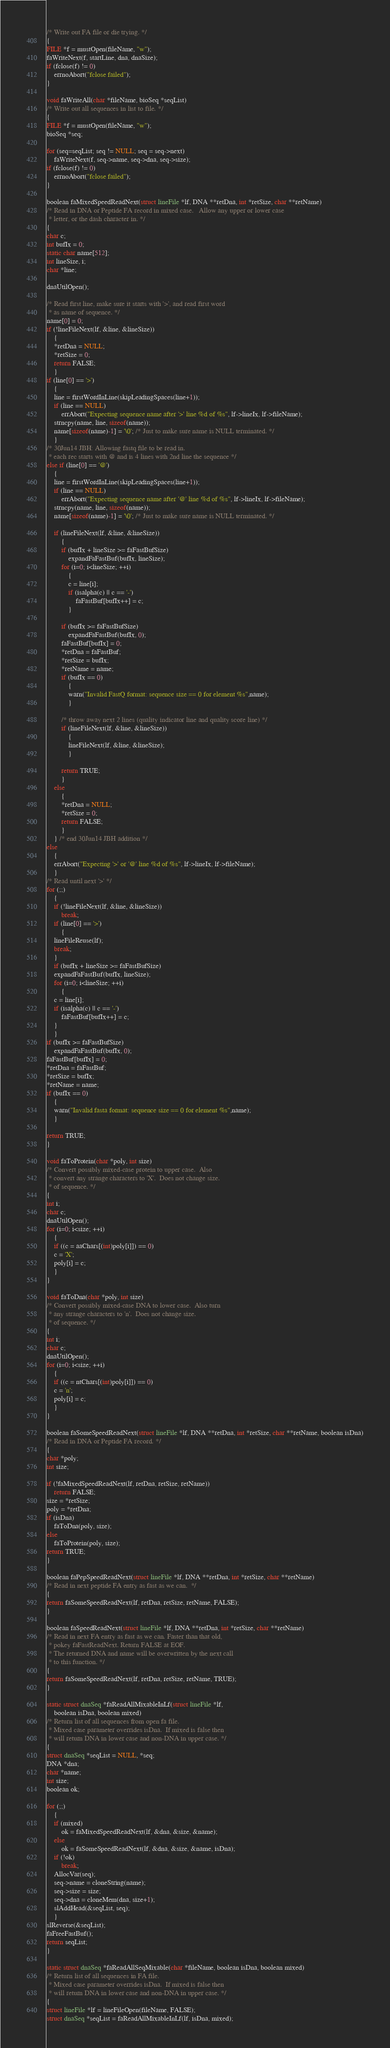<code> <loc_0><loc_0><loc_500><loc_500><_C_>/* Write out FA file or die trying. */
{
FILE *f = mustOpen(fileName, "w");
faWriteNext(f, startLine, dna, dnaSize);
if (fclose(f) != 0)
    errnoAbort("fclose failed");
}

void faWriteAll(char *fileName, bioSeq *seqList)
/* Write out all sequences in list to file. */
{
FILE *f = mustOpen(fileName, "w");
bioSeq *seq;

for (seq=seqList; seq != NULL; seq = seq->next)
    faWriteNext(f, seq->name, seq->dna, seq->size);
if (fclose(f) != 0)
    errnoAbort("fclose failed");
}

boolean faMixedSpeedReadNext(struct lineFile *lf, DNA **retDna, int *retSize, char **retName)
/* Read in DNA or Peptide FA record in mixed case.   Allow any upper or lower case
 * letter, or the dash character in. */
{
char c;
int bufIx = 0;
static char name[512];
int lineSize, i;
char *line;

dnaUtilOpen();

/* Read first line, make sure it starts with '>', and read first word
 * as name of sequence. */
name[0] = 0;
if (!lineFileNext(lf, &line, &lineSize))
    {
    *retDna = NULL;
    *retSize = 0;
    return FALSE;
    }
if (line[0] == '>')
    {
    line = firstWordInLine(skipLeadingSpaces(line+1));
    if (line == NULL)
        errAbort("Expecting sequence name after '>' line %d of %s", lf->lineIx, lf->fileName);
    strncpy(name, line, sizeof(name));
    name[sizeof(name)-1] = '\0'; /* Just to make sure name is NULL terminated. */
    }
/* 30Jun14 JBH: Allowing fastq file to be read in.
 * each rec starts with @ and is 4 lines with 2nd line the sequence */
else if (line[0] == '@')
	{
    line = firstWordInLine(skipLeadingSpaces(line+1));
    if (line == NULL)
        errAbort("Expecting sequence name after '@' line %d of %s", lf->lineIx, lf->fileName);
    strncpy(name, line, sizeof(name));
    name[sizeof(name)-1] = '\0'; /* Just to make sure name is NULL terminated. */

    if (lineFileNext(lf, &line, &lineSize))
		{
		if (bufIx + lineSize >= faFastBufSize)
			expandFaFastBuf(bufIx, lineSize);
		for (i=0; i<lineSize; ++i)
			{
			c = line[i];
			if (isalpha(c) || c == '-')
				faFastBuf[bufIx++] = c;
			}

		if (bufIx >= faFastBufSize)
			expandFaFastBuf(bufIx, 0);
		faFastBuf[bufIx] = 0;
		*retDna = faFastBuf;
		*retSize = bufIx;
		*retName = name;
		if (bufIx == 0)
			{
			warn("Invalid FastQ format: sequence size == 0 for element %s",name);
			}
			
		/* throw away next 2 lines (quality indicator line and quality score line) */
		if (lineFileNext(lf, &line, &lineSize))
			{
		    lineFileNext(lf, &line, &lineSize);
			}
			
		return TRUE;
		}
	else
		{
		*retDna = NULL;
		*retSize = 0;
		return FALSE;
		}
	} /* end 30Jun14 JBH addition */
else
    {
    errAbort("Expecting '>' or '@' line %d of %s", lf->lineIx, lf->fileName);
    }
/* Read until next '>' */
for (;;)
    {
    if (!lineFileNext(lf, &line, &lineSize))
        break;
    if (line[0] == '>')
        {
	lineFileReuse(lf);
	break;
	}
    if (bufIx + lineSize >= faFastBufSize)
	expandFaFastBuf(bufIx, lineSize);
    for (i=0; i<lineSize; ++i)
        {
	c = line[i];
	if (isalpha(c) || c == '-')
	    faFastBuf[bufIx++] = c;
	}
    }
if (bufIx >= faFastBufSize)
    expandFaFastBuf(bufIx, 0);
faFastBuf[bufIx] = 0;
*retDna = faFastBuf;
*retSize = bufIx;
*retName = name;
if (bufIx == 0)
    {
    warn("Invalid fasta format: sequence size == 0 for element %s",name);
    }

return TRUE;
}

void faToProtein(char *poly, int size)
/* Convert possibly mixed-case protein to upper case.  Also
 * convert any strange characters to 'X'.  Does not change size.
 * of sequence. */
{
int i;
char c;
dnaUtilOpen();
for (i=0; i<size; ++i)
    {
    if ((c = aaChars[(int)poly[i]]) == 0)
	c = 'X';
    poly[i] = c;
    }
}

void faToDna(char *poly, int size)
/* Convert possibly mixed-case DNA to lower case.  Also turn
 * any strange characters to 'n'.  Does not change size.
 * of sequence. */
{
int i;
char c;
dnaUtilOpen();
for (i=0; i<size; ++i)
    {
    if ((c = ntChars[(int)poly[i]]) == 0)
	c = 'n';
    poly[i] = c;
    }
}

boolean faSomeSpeedReadNext(struct lineFile *lf, DNA **retDna, int *retSize, char **retName, boolean isDna)
/* Read in DNA or Peptide FA record. */
{
char *poly;
int size;

if (!faMixedSpeedReadNext(lf, retDna, retSize, retName))
    return FALSE;
size = *retSize;
poly = *retDna;
if (isDna)
    faToDna(poly, size);
else
    faToProtein(poly, size);
return TRUE;
}

boolean faPepSpeedReadNext(struct lineFile *lf, DNA **retDna, int *retSize, char **retName)
/* Read in next peptide FA entry as fast as we can.  */
{
return faSomeSpeedReadNext(lf, retDna, retSize, retName, FALSE);
}

boolean faSpeedReadNext(struct lineFile *lf, DNA **retDna, int *retSize, char **retName)
/* Read in next FA entry as fast as we can. Faster than that old,
 * pokey faFastReadNext. Return FALSE at EOF. 
 * The returned DNA and name will be overwritten by the next call
 * to this function. */
{
return faSomeSpeedReadNext(lf, retDna, retSize, retName, TRUE);
}

static struct dnaSeq *faReadAllMixableInLf(struct lineFile *lf, 
	boolean isDna, boolean mixed)
/* Return list of all sequences from open fa file. 
 * Mixed case parameter overrides isDna.  If mixed is false then
 * will return DNA in lower case and non-DNA in upper case. */
{
struct dnaSeq *seqList = NULL, *seq;
DNA *dna;
char *name;
int size;
boolean ok;

for (;;)
    {
    if (mixed)
        ok = faMixedSpeedReadNext(lf, &dna, &size, &name);
    else
        ok = faSomeSpeedReadNext(lf, &dna, &size, &name, isDna);
    if (!ok)
        break;
    AllocVar(seq);
    seq->name = cloneString(name);
    seq->size = size;
    seq->dna = cloneMem(dna, size+1);
    slAddHead(&seqList, seq);
    }
slReverse(&seqList);
faFreeFastBuf();
return seqList;
}

static struct dnaSeq *faReadAllSeqMixable(char *fileName, boolean isDna, boolean mixed)
/* Return list of all sequences in FA file. 
 * Mixed case parameter overrides isDna.  If mixed is false then
 * will return DNA in lower case and non-DNA in upper case. */
{
struct lineFile *lf = lineFileOpen(fileName, FALSE);
struct dnaSeq *seqList = faReadAllMixableInLf(lf, isDna, mixed);</code> 